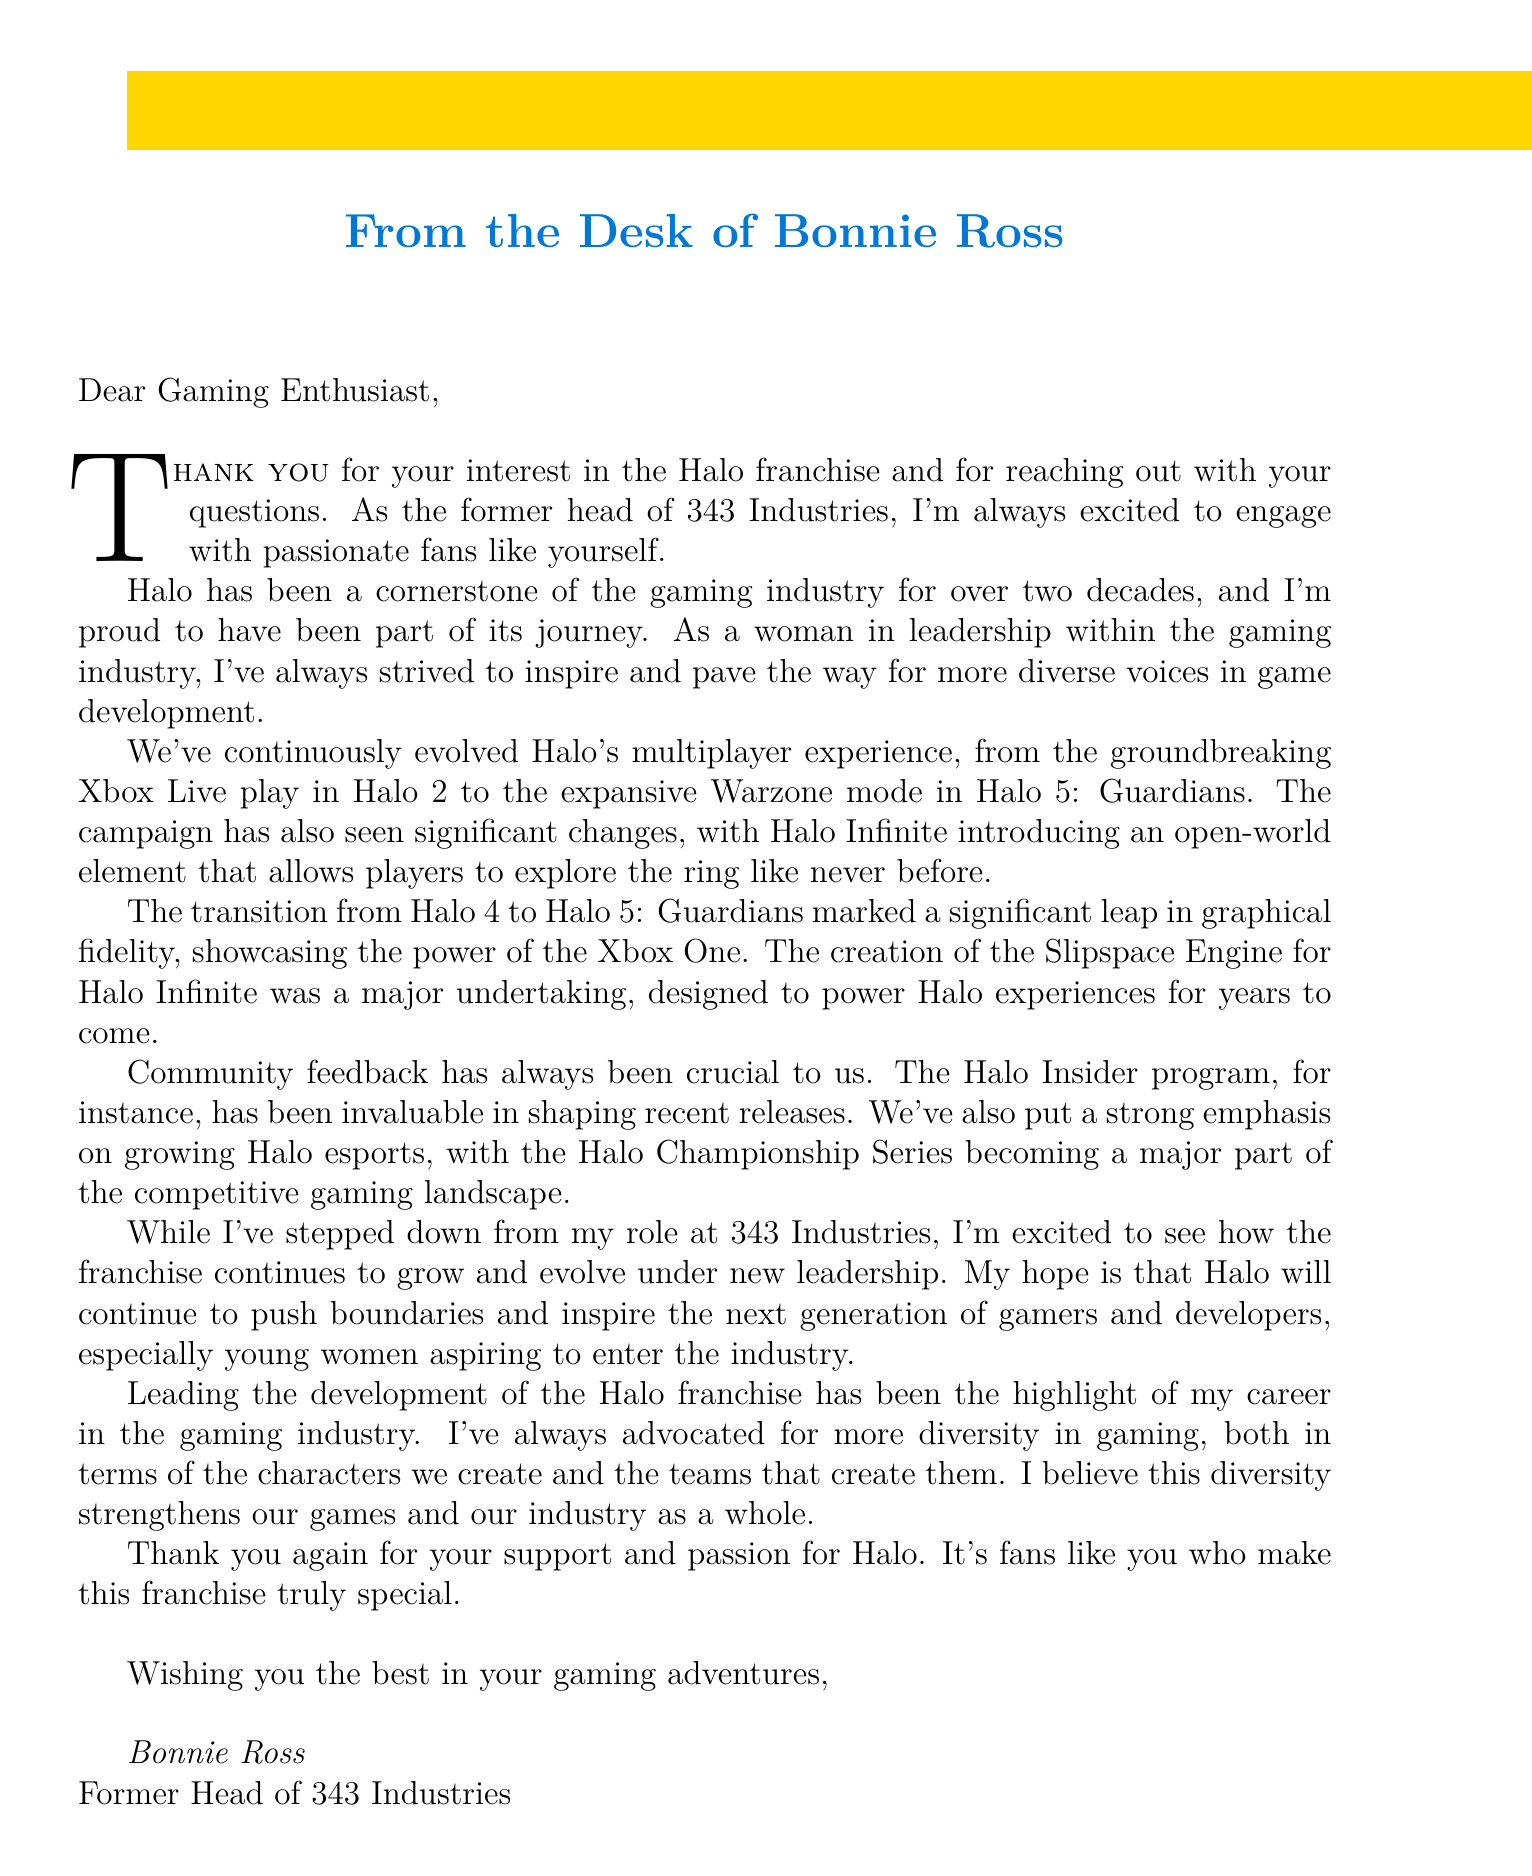What is Bonnie Ross's title? The document states that Bonnie Ross is the "Former Head of 343 Industries."
Answer: Former Head of 343 Industries What aspect of Halo has significantly evolved since Halo 2? The letter mentions a focus on the multiplayer experience, particularly highlighting "groundbreaking Xbox Live play in Halo 2."
Answer: Multiplayer experience What is a major feature introduced in Halo Infinite's campaign? Halo Infinite introduces "an open-world element that allows players to explore the ring like never before."
Answer: Open-world element Which engine was created for Halo Infinite? The letter refers to "the creation of the Slipspace Engine for Halo Infinite."
Answer: Slipspace Engine How long has Halo been a part of the gaming industry? Bonnie Ross expresses that Halo has been a cornerstone for "over two decades."
Answer: Over two decades What does Bonnie Ross hope for the future of Halo? She hopes that "Halo will continue to push boundaries and inspire the next generation of gamers and developers."
Answer: Push boundaries and inspire What is emphasized as important in shaping recent Halo releases? Bonnie Ross highlights the importance of "Community feedback" in shaping releases.
Answer: Community feedback What program is mentioned as crucial for community engagement? The document discusses the "Halo Insider program" as invaluable for feedback.
Answer: Halo Insider program 